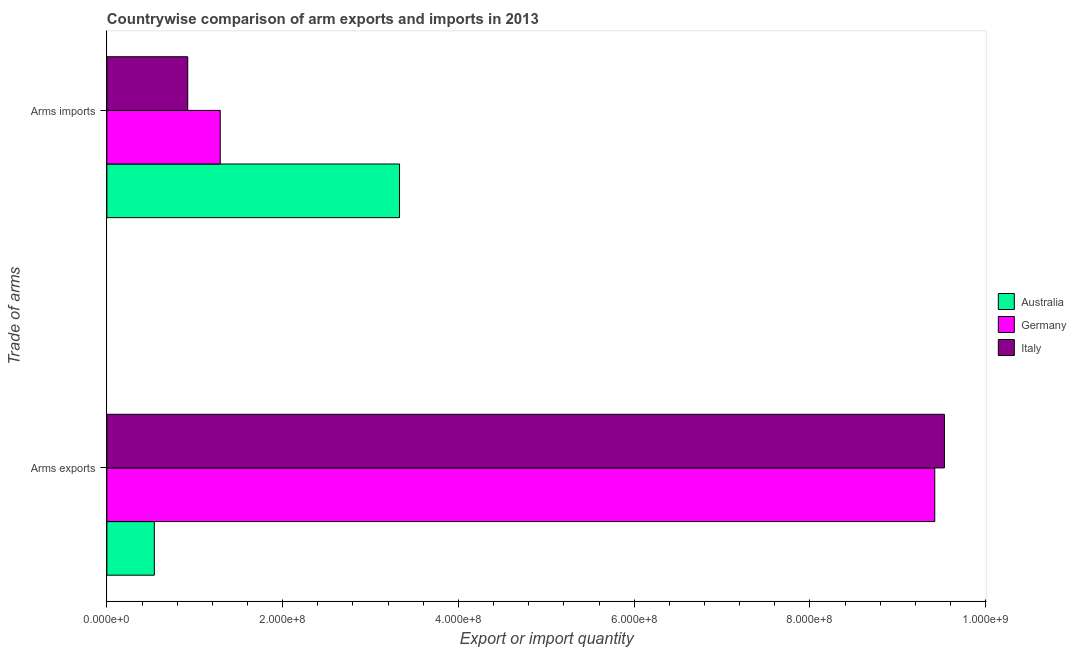Are the number of bars on each tick of the Y-axis equal?
Provide a succinct answer. Yes. How many bars are there on the 2nd tick from the bottom?
Give a very brief answer. 3. What is the label of the 2nd group of bars from the top?
Offer a very short reply. Arms exports. What is the arms exports in Germany?
Ensure brevity in your answer.  9.42e+08. Across all countries, what is the maximum arms exports?
Provide a succinct answer. 9.53e+08. Across all countries, what is the minimum arms imports?
Ensure brevity in your answer.  9.20e+07. In which country was the arms imports maximum?
Provide a succinct answer. Australia. In which country was the arms exports minimum?
Make the answer very short. Australia. What is the total arms imports in the graph?
Make the answer very short. 5.54e+08. What is the difference between the arms exports in Australia and that in Italy?
Offer a very short reply. -8.99e+08. What is the difference between the arms exports in Italy and the arms imports in Germany?
Provide a short and direct response. 8.24e+08. What is the average arms imports per country?
Your response must be concise. 1.85e+08. What is the difference between the arms imports and arms exports in Australia?
Keep it short and to the point. 2.79e+08. In how many countries, is the arms exports greater than 880000000 ?
Provide a succinct answer. 2. What is the ratio of the arms exports in Italy to that in Australia?
Your answer should be very brief. 17.65. Is the arms imports in Australia less than that in Germany?
Ensure brevity in your answer.  No. In how many countries, is the arms exports greater than the average arms exports taken over all countries?
Your answer should be compact. 2. What does the 3rd bar from the top in Arms exports represents?
Your response must be concise. Australia. Are all the bars in the graph horizontal?
Provide a short and direct response. Yes. Does the graph contain grids?
Keep it short and to the point. No. How many legend labels are there?
Your response must be concise. 3. What is the title of the graph?
Give a very brief answer. Countrywise comparison of arm exports and imports in 2013. Does "Marshall Islands" appear as one of the legend labels in the graph?
Offer a very short reply. No. What is the label or title of the X-axis?
Give a very brief answer. Export or import quantity. What is the label or title of the Y-axis?
Make the answer very short. Trade of arms. What is the Export or import quantity of Australia in Arms exports?
Ensure brevity in your answer.  5.40e+07. What is the Export or import quantity of Germany in Arms exports?
Your response must be concise. 9.42e+08. What is the Export or import quantity in Italy in Arms exports?
Give a very brief answer. 9.53e+08. What is the Export or import quantity in Australia in Arms imports?
Your answer should be compact. 3.33e+08. What is the Export or import quantity of Germany in Arms imports?
Make the answer very short. 1.29e+08. What is the Export or import quantity in Italy in Arms imports?
Your answer should be very brief. 9.20e+07. Across all Trade of arms, what is the maximum Export or import quantity of Australia?
Make the answer very short. 3.33e+08. Across all Trade of arms, what is the maximum Export or import quantity in Germany?
Provide a succinct answer. 9.42e+08. Across all Trade of arms, what is the maximum Export or import quantity of Italy?
Offer a very short reply. 9.53e+08. Across all Trade of arms, what is the minimum Export or import quantity in Australia?
Ensure brevity in your answer.  5.40e+07. Across all Trade of arms, what is the minimum Export or import quantity in Germany?
Provide a short and direct response. 1.29e+08. Across all Trade of arms, what is the minimum Export or import quantity in Italy?
Your answer should be very brief. 9.20e+07. What is the total Export or import quantity in Australia in the graph?
Give a very brief answer. 3.87e+08. What is the total Export or import quantity of Germany in the graph?
Offer a very short reply. 1.07e+09. What is the total Export or import quantity of Italy in the graph?
Provide a succinct answer. 1.04e+09. What is the difference between the Export or import quantity in Australia in Arms exports and that in Arms imports?
Your response must be concise. -2.79e+08. What is the difference between the Export or import quantity in Germany in Arms exports and that in Arms imports?
Your answer should be compact. 8.13e+08. What is the difference between the Export or import quantity in Italy in Arms exports and that in Arms imports?
Offer a very short reply. 8.61e+08. What is the difference between the Export or import quantity in Australia in Arms exports and the Export or import quantity in Germany in Arms imports?
Your answer should be compact. -7.50e+07. What is the difference between the Export or import quantity of Australia in Arms exports and the Export or import quantity of Italy in Arms imports?
Offer a very short reply. -3.80e+07. What is the difference between the Export or import quantity of Germany in Arms exports and the Export or import quantity of Italy in Arms imports?
Your response must be concise. 8.50e+08. What is the average Export or import quantity of Australia per Trade of arms?
Offer a very short reply. 1.94e+08. What is the average Export or import quantity of Germany per Trade of arms?
Give a very brief answer. 5.36e+08. What is the average Export or import quantity in Italy per Trade of arms?
Make the answer very short. 5.22e+08. What is the difference between the Export or import quantity in Australia and Export or import quantity in Germany in Arms exports?
Your response must be concise. -8.88e+08. What is the difference between the Export or import quantity in Australia and Export or import quantity in Italy in Arms exports?
Offer a very short reply. -8.99e+08. What is the difference between the Export or import quantity of Germany and Export or import quantity of Italy in Arms exports?
Give a very brief answer. -1.10e+07. What is the difference between the Export or import quantity in Australia and Export or import quantity in Germany in Arms imports?
Give a very brief answer. 2.04e+08. What is the difference between the Export or import quantity in Australia and Export or import quantity in Italy in Arms imports?
Provide a short and direct response. 2.41e+08. What is the difference between the Export or import quantity of Germany and Export or import quantity of Italy in Arms imports?
Make the answer very short. 3.70e+07. What is the ratio of the Export or import quantity in Australia in Arms exports to that in Arms imports?
Your response must be concise. 0.16. What is the ratio of the Export or import quantity of Germany in Arms exports to that in Arms imports?
Give a very brief answer. 7.3. What is the ratio of the Export or import quantity of Italy in Arms exports to that in Arms imports?
Give a very brief answer. 10.36. What is the difference between the highest and the second highest Export or import quantity in Australia?
Ensure brevity in your answer.  2.79e+08. What is the difference between the highest and the second highest Export or import quantity of Germany?
Give a very brief answer. 8.13e+08. What is the difference between the highest and the second highest Export or import quantity in Italy?
Offer a terse response. 8.61e+08. What is the difference between the highest and the lowest Export or import quantity in Australia?
Give a very brief answer. 2.79e+08. What is the difference between the highest and the lowest Export or import quantity of Germany?
Offer a terse response. 8.13e+08. What is the difference between the highest and the lowest Export or import quantity of Italy?
Your answer should be compact. 8.61e+08. 